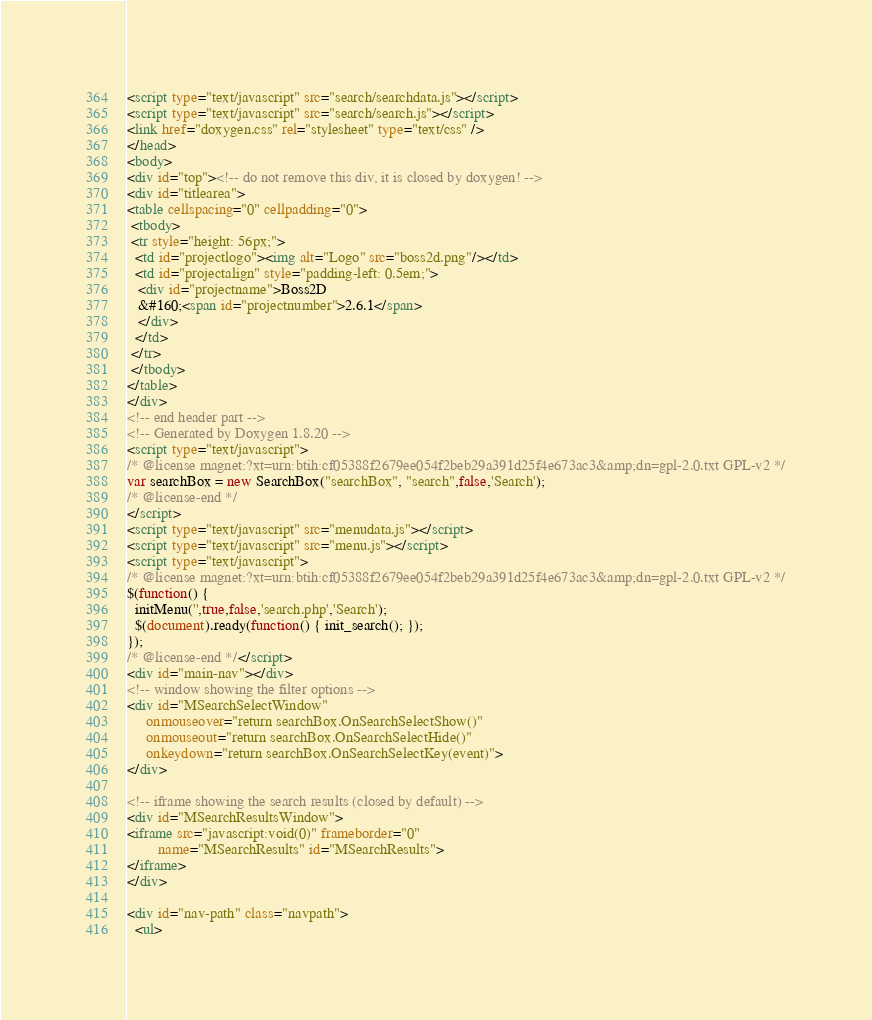<code> <loc_0><loc_0><loc_500><loc_500><_HTML_><script type="text/javascript" src="search/searchdata.js"></script>
<script type="text/javascript" src="search/search.js"></script>
<link href="doxygen.css" rel="stylesheet" type="text/css" />
</head>
<body>
<div id="top"><!-- do not remove this div, it is closed by doxygen! -->
<div id="titlearea">
<table cellspacing="0" cellpadding="0">
 <tbody>
 <tr style="height: 56px;">
  <td id="projectlogo"><img alt="Logo" src="boss2d.png"/></td>
  <td id="projectalign" style="padding-left: 0.5em;">
   <div id="projectname">Boss2D
   &#160;<span id="projectnumber">2.6.1</span>
   </div>
  </td>
 </tr>
 </tbody>
</table>
</div>
<!-- end header part -->
<!-- Generated by Doxygen 1.8.20 -->
<script type="text/javascript">
/* @license magnet:?xt=urn:btih:cf05388f2679ee054f2beb29a391d25f4e673ac3&amp;dn=gpl-2.0.txt GPL-v2 */
var searchBox = new SearchBox("searchBox", "search",false,'Search');
/* @license-end */
</script>
<script type="text/javascript" src="menudata.js"></script>
<script type="text/javascript" src="menu.js"></script>
<script type="text/javascript">
/* @license magnet:?xt=urn:btih:cf05388f2679ee054f2beb29a391d25f4e673ac3&amp;dn=gpl-2.0.txt GPL-v2 */
$(function() {
  initMenu('',true,false,'search.php','Search');
  $(document).ready(function() { init_search(); });
});
/* @license-end */</script>
<div id="main-nav"></div>
<!-- window showing the filter options -->
<div id="MSearchSelectWindow"
     onmouseover="return searchBox.OnSearchSelectShow()"
     onmouseout="return searchBox.OnSearchSelectHide()"
     onkeydown="return searchBox.OnSearchSelectKey(event)">
</div>

<!-- iframe showing the search results (closed by default) -->
<div id="MSearchResultsWindow">
<iframe src="javascript:void(0)" frameborder="0" 
        name="MSearchResults" id="MSearchResults">
</iframe>
</div>

<div id="nav-path" class="navpath">
  <ul></code> 